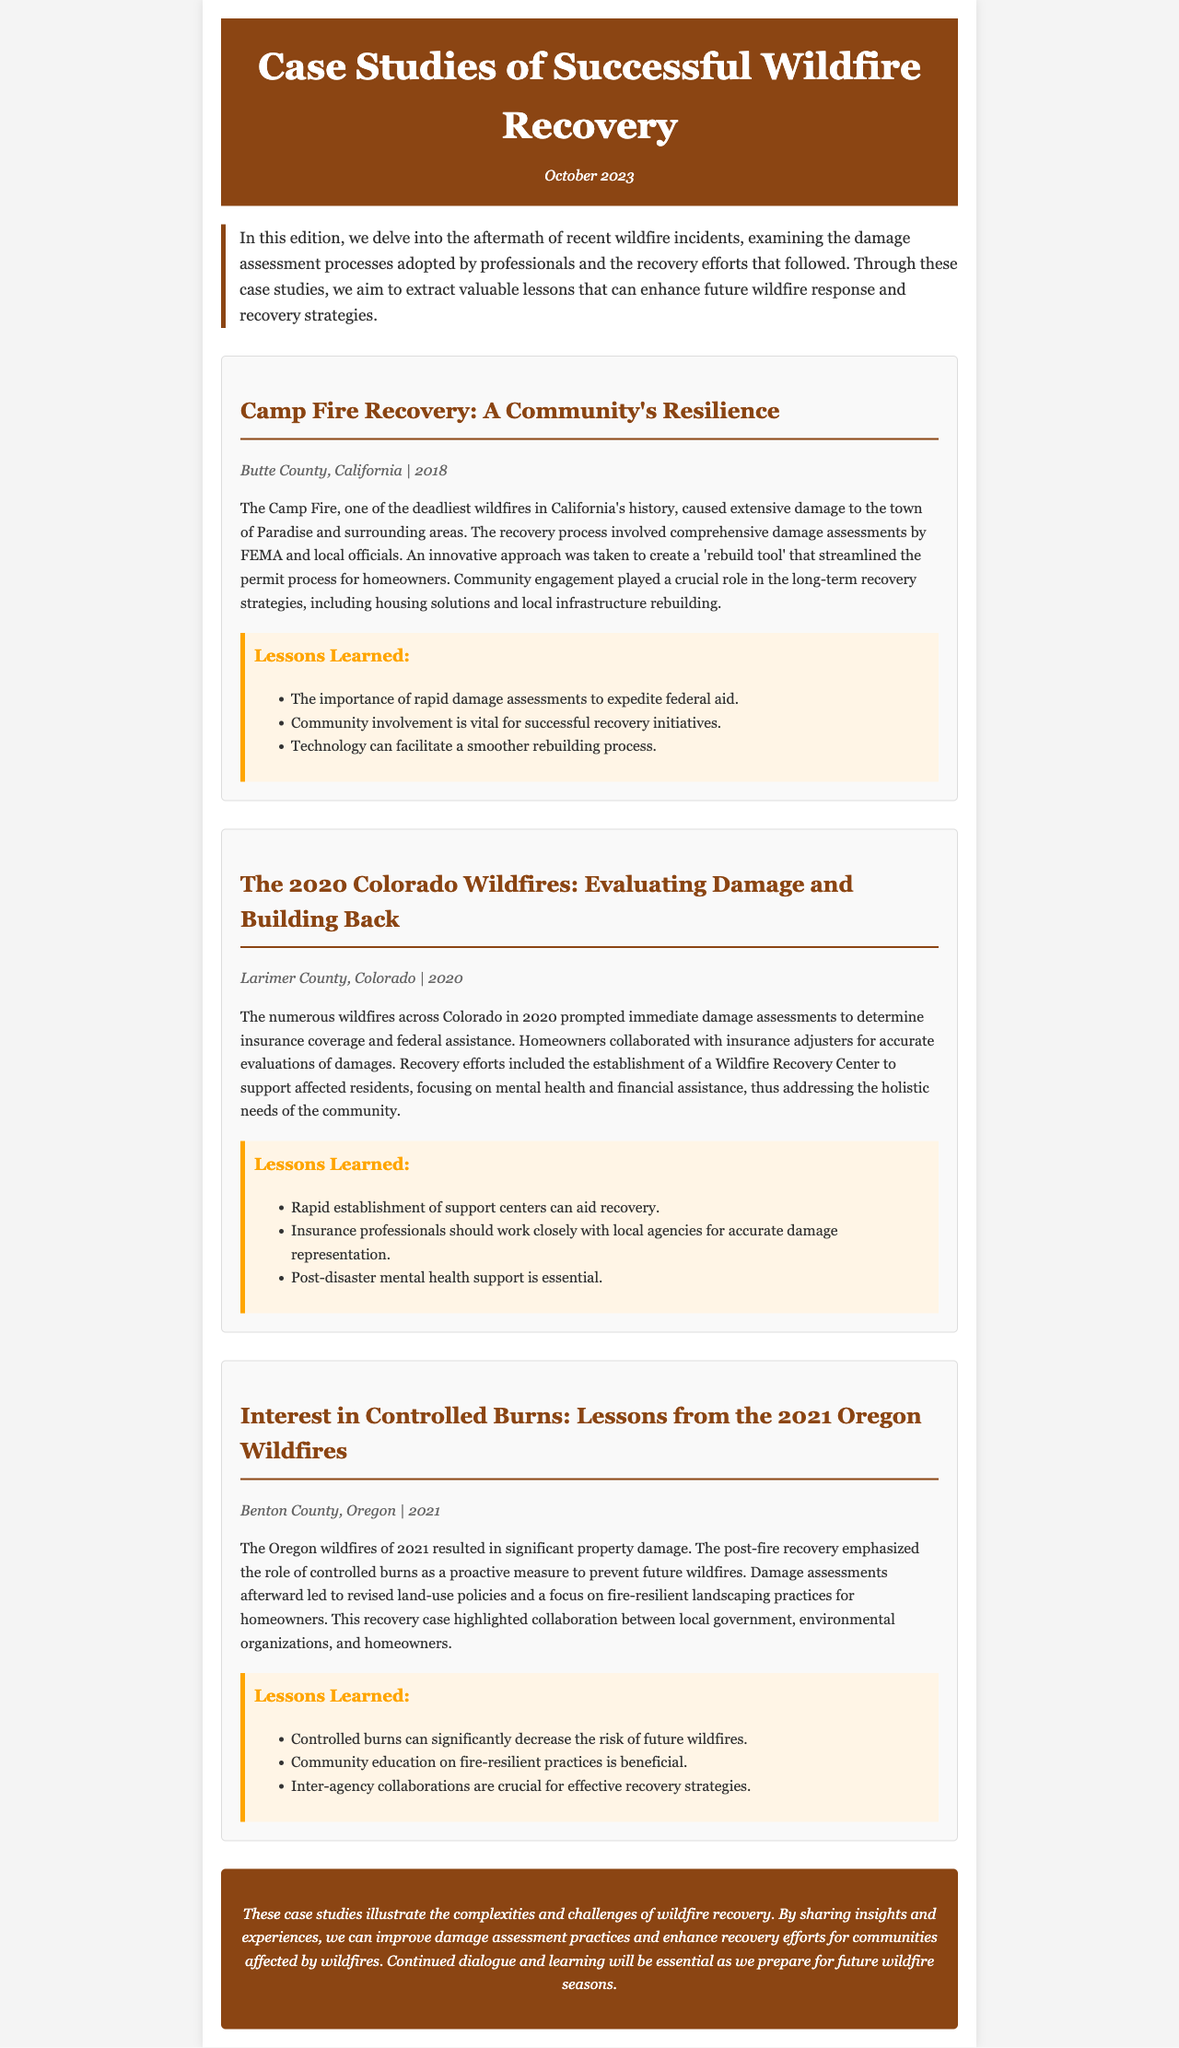What is the title of the newsletter? The title of the newsletter is provided at the beginning of the document.
Answer: Case Studies of Successful Wildfire Recovery What year did the Camp Fire occur? The occurrence year is noted in the case study information for the Camp Fire.
Answer: 2018 What was established to support residents after the 2020 Colorado wildfires? The 2020 Colorado wildfire case study mentions a specific center that was set up.
Answer: Wildfire Recovery Center Which county experienced the 2021 Oregon wildfires? The case study for the 2021 wildfires lists it under a specific county.
Answer: Benton County What specific approach was emphasized in the 2021 Oregon wildfires recovery? The document mentions an important method in recovery efforts post the Oregon wildfires.
Answer: Controlled burns How did community involvement impact the Camp Fire recovery? The Camp Fire case study highlights a particular aspect of recovery relating to community engagement.
Answer: Crucial role What is a key lesson from the 2020 Colorado wildfires case study? Each case study section lists lessons learned, highlighting significant points for recovery.
Answer: Mental health support is essential What is the main theme of the newsletter? The introduction provides an overview of the newsletter's subject matter.
Answer: Wildfire recovery efforts and damage assessments What color is used for the header of the document? The styling details in the document describe the header's color.
Answer: Brown 